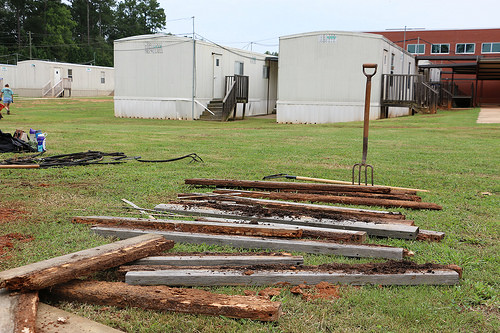<image>
Can you confirm if the fork is behind the wood? Yes. From this viewpoint, the fork is positioned behind the wood, with the wood partially or fully occluding the fork. Is there a rake in the wood? Yes. The rake is contained within or inside the wood, showing a containment relationship. 